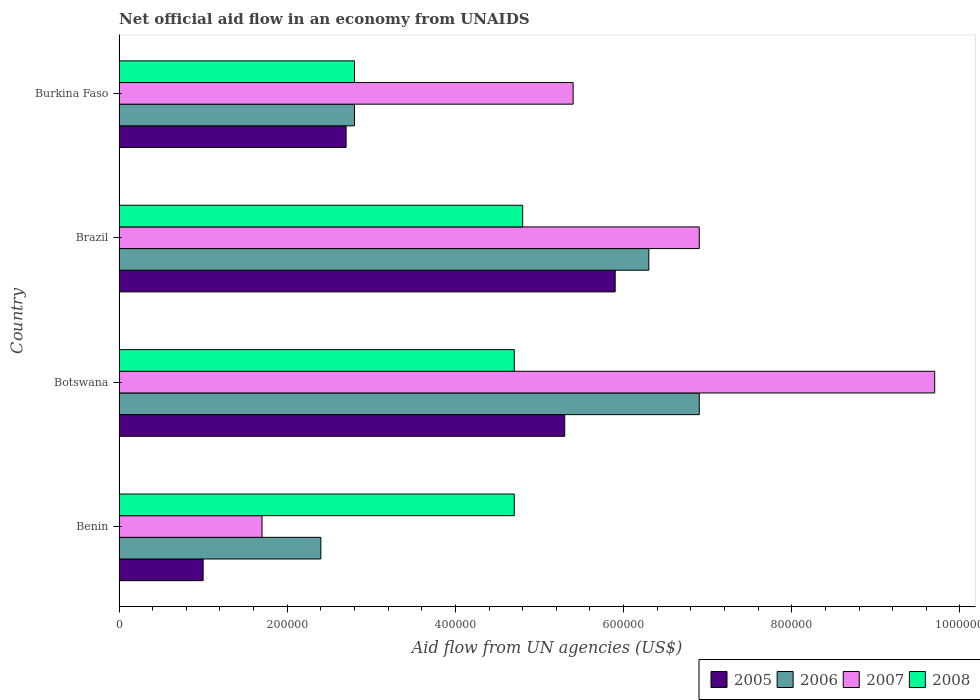How many different coloured bars are there?
Make the answer very short. 4. Are the number of bars on each tick of the Y-axis equal?
Ensure brevity in your answer.  Yes. How many bars are there on the 3rd tick from the top?
Your response must be concise. 4. How many bars are there on the 3rd tick from the bottom?
Offer a very short reply. 4. What is the label of the 2nd group of bars from the top?
Your answer should be compact. Brazil. What is the net official aid flow in 2007 in Brazil?
Keep it short and to the point. 6.90e+05. Across all countries, what is the maximum net official aid flow in 2006?
Your response must be concise. 6.90e+05. Across all countries, what is the minimum net official aid flow in 2005?
Offer a terse response. 1.00e+05. In which country was the net official aid flow in 2008 maximum?
Your response must be concise. Brazil. In which country was the net official aid flow in 2006 minimum?
Give a very brief answer. Benin. What is the total net official aid flow in 2007 in the graph?
Your answer should be compact. 2.37e+06. What is the difference between the net official aid flow in 2008 in Burkina Faso and the net official aid flow in 2006 in Benin?
Provide a short and direct response. 4.00e+04. What is the average net official aid flow in 2008 per country?
Provide a succinct answer. 4.25e+05. What is the difference between the net official aid flow in 2007 and net official aid flow in 2006 in Botswana?
Keep it short and to the point. 2.80e+05. What is the ratio of the net official aid flow in 2008 in Benin to that in Burkina Faso?
Provide a short and direct response. 1.68. What is the difference between the highest and the lowest net official aid flow in 2007?
Your answer should be compact. 8.00e+05. Is it the case that in every country, the sum of the net official aid flow in 2005 and net official aid flow in 2006 is greater than the sum of net official aid flow in 2008 and net official aid flow in 2007?
Offer a terse response. No. What does the 3rd bar from the top in Brazil represents?
Provide a short and direct response. 2006. Are all the bars in the graph horizontal?
Offer a very short reply. Yes. Are the values on the major ticks of X-axis written in scientific E-notation?
Offer a very short reply. No. Where does the legend appear in the graph?
Give a very brief answer. Bottom right. How many legend labels are there?
Ensure brevity in your answer.  4. What is the title of the graph?
Your response must be concise. Net official aid flow in an economy from UNAIDS. What is the label or title of the X-axis?
Offer a very short reply. Aid flow from UN agencies (US$). What is the Aid flow from UN agencies (US$) in 2005 in Benin?
Provide a succinct answer. 1.00e+05. What is the Aid flow from UN agencies (US$) of 2006 in Benin?
Provide a short and direct response. 2.40e+05. What is the Aid flow from UN agencies (US$) in 2005 in Botswana?
Offer a terse response. 5.30e+05. What is the Aid flow from UN agencies (US$) in 2006 in Botswana?
Provide a succinct answer. 6.90e+05. What is the Aid flow from UN agencies (US$) in 2007 in Botswana?
Your response must be concise. 9.70e+05. What is the Aid flow from UN agencies (US$) of 2005 in Brazil?
Your response must be concise. 5.90e+05. What is the Aid flow from UN agencies (US$) in 2006 in Brazil?
Your answer should be compact. 6.30e+05. What is the Aid flow from UN agencies (US$) in 2007 in Brazil?
Your response must be concise. 6.90e+05. What is the Aid flow from UN agencies (US$) in 2006 in Burkina Faso?
Provide a short and direct response. 2.80e+05. What is the Aid flow from UN agencies (US$) in 2007 in Burkina Faso?
Give a very brief answer. 5.40e+05. What is the Aid flow from UN agencies (US$) in 2008 in Burkina Faso?
Your answer should be very brief. 2.80e+05. Across all countries, what is the maximum Aid flow from UN agencies (US$) in 2005?
Give a very brief answer. 5.90e+05. Across all countries, what is the maximum Aid flow from UN agencies (US$) in 2006?
Provide a short and direct response. 6.90e+05. Across all countries, what is the maximum Aid flow from UN agencies (US$) of 2007?
Ensure brevity in your answer.  9.70e+05. Across all countries, what is the minimum Aid flow from UN agencies (US$) in 2006?
Give a very brief answer. 2.40e+05. Across all countries, what is the minimum Aid flow from UN agencies (US$) in 2007?
Your answer should be compact. 1.70e+05. What is the total Aid flow from UN agencies (US$) in 2005 in the graph?
Offer a very short reply. 1.49e+06. What is the total Aid flow from UN agencies (US$) of 2006 in the graph?
Provide a succinct answer. 1.84e+06. What is the total Aid flow from UN agencies (US$) in 2007 in the graph?
Make the answer very short. 2.37e+06. What is the total Aid flow from UN agencies (US$) in 2008 in the graph?
Keep it short and to the point. 1.70e+06. What is the difference between the Aid flow from UN agencies (US$) in 2005 in Benin and that in Botswana?
Your response must be concise. -4.30e+05. What is the difference between the Aid flow from UN agencies (US$) in 2006 in Benin and that in Botswana?
Provide a short and direct response. -4.50e+05. What is the difference between the Aid flow from UN agencies (US$) in 2007 in Benin and that in Botswana?
Your answer should be very brief. -8.00e+05. What is the difference between the Aid flow from UN agencies (US$) in 2008 in Benin and that in Botswana?
Your answer should be compact. 0. What is the difference between the Aid flow from UN agencies (US$) in 2005 in Benin and that in Brazil?
Your answer should be compact. -4.90e+05. What is the difference between the Aid flow from UN agencies (US$) of 2006 in Benin and that in Brazil?
Give a very brief answer. -3.90e+05. What is the difference between the Aid flow from UN agencies (US$) in 2007 in Benin and that in Brazil?
Your answer should be very brief. -5.20e+05. What is the difference between the Aid flow from UN agencies (US$) in 2008 in Benin and that in Brazil?
Your answer should be very brief. -10000. What is the difference between the Aid flow from UN agencies (US$) of 2005 in Benin and that in Burkina Faso?
Make the answer very short. -1.70e+05. What is the difference between the Aid flow from UN agencies (US$) of 2006 in Benin and that in Burkina Faso?
Offer a terse response. -4.00e+04. What is the difference between the Aid flow from UN agencies (US$) in 2007 in Benin and that in Burkina Faso?
Your answer should be very brief. -3.70e+05. What is the difference between the Aid flow from UN agencies (US$) in 2008 in Benin and that in Burkina Faso?
Offer a very short reply. 1.90e+05. What is the difference between the Aid flow from UN agencies (US$) in 2008 in Botswana and that in Brazil?
Your answer should be compact. -10000. What is the difference between the Aid flow from UN agencies (US$) in 2007 in Botswana and that in Burkina Faso?
Make the answer very short. 4.30e+05. What is the difference between the Aid flow from UN agencies (US$) of 2008 in Botswana and that in Burkina Faso?
Provide a short and direct response. 1.90e+05. What is the difference between the Aid flow from UN agencies (US$) of 2005 in Brazil and that in Burkina Faso?
Your answer should be compact. 3.20e+05. What is the difference between the Aid flow from UN agencies (US$) in 2006 in Brazil and that in Burkina Faso?
Your response must be concise. 3.50e+05. What is the difference between the Aid flow from UN agencies (US$) in 2008 in Brazil and that in Burkina Faso?
Offer a very short reply. 2.00e+05. What is the difference between the Aid flow from UN agencies (US$) of 2005 in Benin and the Aid flow from UN agencies (US$) of 2006 in Botswana?
Offer a terse response. -5.90e+05. What is the difference between the Aid flow from UN agencies (US$) of 2005 in Benin and the Aid flow from UN agencies (US$) of 2007 in Botswana?
Keep it short and to the point. -8.70e+05. What is the difference between the Aid flow from UN agencies (US$) of 2005 in Benin and the Aid flow from UN agencies (US$) of 2008 in Botswana?
Give a very brief answer. -3.70e+05. What is the difference between the Aid flow from UN agencies (US$) of 2006 in Benin and the Aid flow from UN agencies (US$) of 2007 in Botswana?
Your answer should be very brief. -7.30e+05. What is the difference between the Aid flow from UN agencies (US$) of 2007 in Benin and the Aid flow from UN agencies (US$) of 2008 in Botswana?
Offer a very short reply. -3.00e+05. What is the difference between the Aid flow from UN agencies (US$) of 2005 in Benin and the Aid flow from UN agencies (US$) of 2006 in Brazil?
Give a very brief answer. -5.30e+05. What is the difference between the Aid flow from UN agencies (US$) in 2005 in Benin and the Aid flow from UN agencies (US$) in 2007 in Brazil?
Give a very brief answer. -5.90e+05. What is the difference between the Aid flow from UN agencies (US$) in 2005 in Benin and the Aid flow from UN agencies (US$) in 2008 in Brazil?
Your response must be concise. -3.80e+05. What is the difference between the Aid flow from UN agencies (US$) of 2006 in Benin and the Aid flow from UN agencies (US$) of 2007 in Brazil?
Make the answer very short. -4.50e+05. What is the difference between the Aid flow from UN agencies (US$) of 2007 in Benin and the Aid flow from UN agencies (US$) of 2008 in Brazil?
Offer a very short reply. -3.10e+05. What is the difference between the Aid flow from UN agencies (US$) in 2005 in Benin and the Aid flow from UN agencies (US$) in 2006 in Burkina Faso?
Offer a terse response. -1.80e+05. What is the difference between the Aid flow from UN agencies (US$) in 2005 in Benin and the Aid flow from UN agencies (US$) in 2007 in Burkina Faso?
Offer a terse response. -4.40e+05. What is the difference between the Aid flow from UN agencies (US$) of 2005 in Benin and the Aid flow from UN agencies (US$) of 2008 in Burkina Faso?
Your response must be concise. -1.80e+05. What is the difference between the Aid flow from UN agencies (US$) of 2006 in Benin and the Aid flow from UN agencies (US$) of 2007 in Burkina Faso?
Give a very brief answer. -3.00e+05. What is the difference between the Aid flow from UN agencies (US$) of 2005 in Botswana and the Aid flow from UN agencies (US$) of 2007 in Brazil?
Provide a succinct answer. -1.60e+05. What is the difference between the Aid flow from UN agencies (US$) of 2006 in Botswana and the Aid flow from UN agencies (US$) of 2007 in Brazil?
Give a very brief answer. 0. What is the difference between the Aid flow from UN agencies (US$) in 2007 in Botswana and the Aid flow from UN agencies (US$) in 2008 in Brazil?
Provide a succinct answer. 4.90e+05. What is the difference between the Aid flow from UN agencies (US$) in 2005 in Botswana and the Aid flow from UN agencies (US$) in 2006 in Burkina Faso?
Provide a succinct answer. 2.50e+05. What is the difference between the Aid flow from UN agencies (US$) in 2005 in Botswana and the Aid flow from UN agencies (US$) in 2007 in Burkina Faso?
Your response must be concise. -10000. What is the difference between the Aid flow from UN agencies (US$) of 2006 in Botswana and the Aid flow from UN agencies (US$) of 2007 in Burkina Faso?
Provide a succinct answer. 1.50e+05. What is the difference between the Aid flow from UN agencies (US$) in 2007 in Botswana and the Aid flow from UN agencies (US$) in 2008 in Burkina Faso?
Keep it short and to the point. 6.90e+05. What is the difference between the Aid flow from UN agencies (US$) in 2005 in Brazil and the Aid flow from UN agencies (US$) in 2007 in Burkina Faso?
Provide a succinct answer. 5.00e+04. What is the difference between the Aid flow from UN agencies (US$) in 2005 in Brazil and the Aid flow from UN agencies (US$) in 2008 in Burkina Faso?
Provide a succinct answer. 3.10e+05. What is the average Aid flow from UN agencies (US$) of 2005 per country?
Provide a succinct answer. 3.72e+05. What is the average Aid flow from UN agencies (US$) of 2006 per country?
Make the answer very short. 4.60e+05. What is the average Aid flow from UN agencies (US$) in 2007 per country?
Provide a short and direct response. 5.92e+05. What is the average Aid flow from UN agencies (US$) in 2008 per country?
Provide a short and direct response. 4.25e+05. What is the difference between the Aid flow from UN agencies (US$) of 2005 and Aid flow from UN agencies (US$) of 2006 in Benin?
Your answer should be compact. -1.40e+05. What is the difference between the Aid flow from UN agencies (US$) of 2005 and Aid flow from UN agencies (US$) of 2008 in Benin?
Make the answer very short. -3.70e+05. What is the difference between the Aid flow from UN agencies (US$) in 2006 and Aid flow from UN agencies (US$) in 2007 in Benin?
Ensure brevity in your answer.  7.00e+04. What is the difference between the Aid flow from UN agencies (US$) of 2006 and Aid flow from UN agencies (US$) of 2008 in Benin?
Your answer should be compact. -2.30e+05. What is the difference between the Aid flow from UN agencies (US$) of 2005 and Aid flow from UN agencies (US$) of 2007 in Botswana?
Ensure brevity in your answer.  -4.40e+05. What is the difference between the Aid flow from UN agencies (US$) of 2005 and Aid flow from UN agencies (US$) of 2008 in Botswana?
Keep it short and to the point. 6.00e+04. What is the difference between the Aid flow from UN agencies (US$) of 2006 and Aid flow from UN agencies (US$) of 2007 in Botswana?
Make the answer very short. -2.80e+05. What is the difference between the Aid flow from UN agencies (US$) in 2005 and Aid flow from UN agencies (US$) in 2008 in Brazil?
Offer a terse response. 1.10e+05. What is the difference between the Aid flow from UN agencies (US$) in 2006 and Aid flow from UN agencies (US$) in 2007 in Brazil?
Your response must be concise. -6.00e+04. What is the difference between the Aid flow from UN agencies (US$) in 2006 and Aid flow from UN agencies (US$) in 2008 in Brazil?
Provide a short and direct response. 1.50e+05. What is the difference between the Aid flow from UN agencies (US$) in 2005 and Aid flow from UN agencies (US$) in 2006 in Burkina Faso?
Your response must be concise. -10000. What is the difference between the Aid flow from UN agencies (US$) of 2005 and Aid flow from UN agencies (US$) of 2007 in Burkina Faso?
Ensure brevity in your answer.  -2.70e+05. What is the difference between the Aid flow from UN agencies (US$) in 2006 and Aid flow from UN agencies (US$) in 2007 in Burkina Faso?
Ensure brevity in your answer.  -2.60e+05. What is the difference between the Aid flow from UN agencies (US$) of 2006 and Aid flow from UN agencies (US$) of 2008 in Burkina Faso?
Keep it short and to the point. 0. What is the difference between the Aid flow from UN agencies (US$) in 2007 and Aid flow from UN agencies (US$) in 2008 in Burkina Faso?
Give a very brief answer. 2.60e+05. What is the ratio of the Aid flow from UN agencies (US$) in 2005 in Benin to that in Botswana?
Give a very brief answer. 0.19. What is the ratio of the Aid flow from UN agencies (US$) of 2006 in Benin to that in Botswana?
Provide a succinct answer. 0.35. What is the ratio of the Aid flow from UN agencies (US$) of 2007 in Benin to that in Botswana?
Your answer should be compact. 0.18. What is the ratio of the Aid flow from UN agencies (US$) in 2008 in Benin to that in Botswana?
Ensure brevity in your answer.  1. What is the ratio of the Aid flow from UN agencies (US$) of 2005 in Benin to that in Brazil?
Ensure brevity in your answer.  0.17. What is the ratio of the Aid flow from UN agencies (US$) in 2006 in Benin to that in Brazil?
Provide a short and direct response. 0.38. What is the ratio of the Aid flow from UN agencies (US$) in 2007 in Benin to that in Brazil?
Offer a terse response. 0.25. What is the ratio of the Aid flow from UN agencies (US$) in 2008 in Benin to that in Brazil?
Offer a terse response. 0.98. What is the ratio of the Aid flow from UN agencies (US$) in 2005 in Benin to that in Burkina Faso?
Offer a very short reply. 0.37. What is the ratio of the Aid flow from UN agencies (US$) in 2006 in Benin to that in Burkina Faso?
Provide a short and direct response. 0.86. What is the ratio of the Aid flow from UN agencies (US$) of 2007 in Benin to that in Burkina Faso?
Your response must be concise. 0.31. What is the ratio of the Aid flow from UN agencies (US$) in 2008 in Benin to that in Burkina Faso?
Ensure brevity in your answer.  1.68. What is the ratio of the Aid flow from UN agencies (US$) of 2005 in Botswana to that in Brazil?
Your answer should be compact. 0.9. What is the ratio of the Aid flow from UN agencies (US$) in 2006 in Botswana to that in Brazil?
Offer a very short reply. 1.1. What is the ratio of the Aid flow from UN agencies (US$) in 2007 in Botswana to that in Brazil?
Provide a succinct answer. 1.41. What is the ratio of the Aid flow from UN agencies (US$) in 2008 in Botswana to that in Brazil?
Give a very brief answer. 0.98. What is the ratio of the Aid flow from UN agencies (US$) of 2005 in Botswana to that in Burkina Faso?
Offer a terse response. 1.96. What is the ratio of the Aid flow from UN agencies (US$) of 2006 in Botswana to that in Burkina Faso?
Make the answer very short. 2.46. What is the ratio of the Aid flow from UN agencies (US$) in 2007 in Botswana to that in Burkina Faso?
Your response must be concise. 1.8. What is the ratio of the Aid flow from UN agencies (US$) in 2008 in Botswana to that in Burkina Faso?
Your answer should be very brief. 1.68. What is the ratio of the Aid flow from UN agencies (US$) in 2005 in Brazil to that in Burkina Faso?
Provide a short and direct response. 2.19. What is the ratio of the Aid flow from UN agencies (US$) in 2006 in Brazil to that in Burkina Faso?
Your answer should be very brief. 2.25. What is the ratio of the Aid flow from UN agencies (US$) in 2007 in Brazil to that in Burkina Faso?
Give a very brief answer. 1.28. What is the ratio of the Aid flow from UN agencies (US$) in 2008 in Brazil to that in Burkina Faso?
Your answer should be compact. 1.71. What is the difference between the highest and the second highest Aid flow from UN agencies (US$) of 2007?
Keep it short and to the point. 2.80e+05. What is the difference between the highest and the lowest Aid flow from UN agencies (US$) in 2006?
Make the answer very short. 4.50e+05. What is the difference between the highest and the lowest Aid flow from UN agencies (US$) of 2007?
Your response must be concise. 8.00e+05. What is the difference between the highest and the lowest Aid flow from UN agencies (US$) in 2008?
Provide a short and direct response. 2.00e+05. 